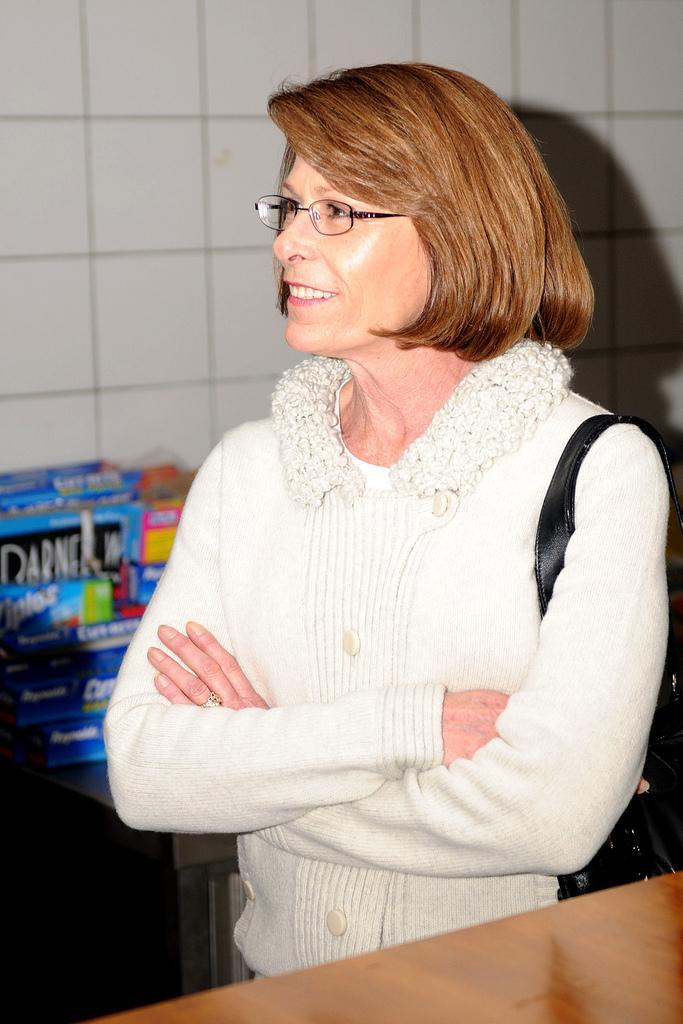In one or two sentences, can you explain what this image depicts? There is a lady standing in the foreground area of the image, it seems like a table at the bottom side and cardboard boxes in the background. 